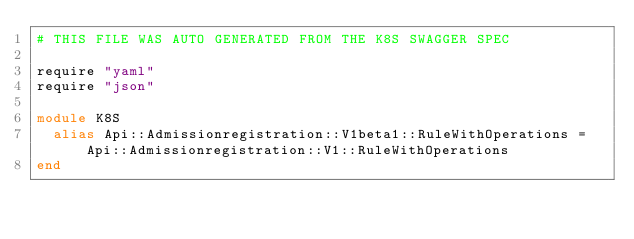Convert code to text. <code><loc_0><loc_0><loc_500><loc_500><_Crystal_># THIS FILE WAS AUTO GENERATED FROM THE K8S SWAGGER SPEC

require "yaml"
require "json"

module K8S
  alias Api::Admissionregistration::V1beta1::RuleWithOperations = Api::Admissionregistration::V1::RuleWithOperations
end
</code> 